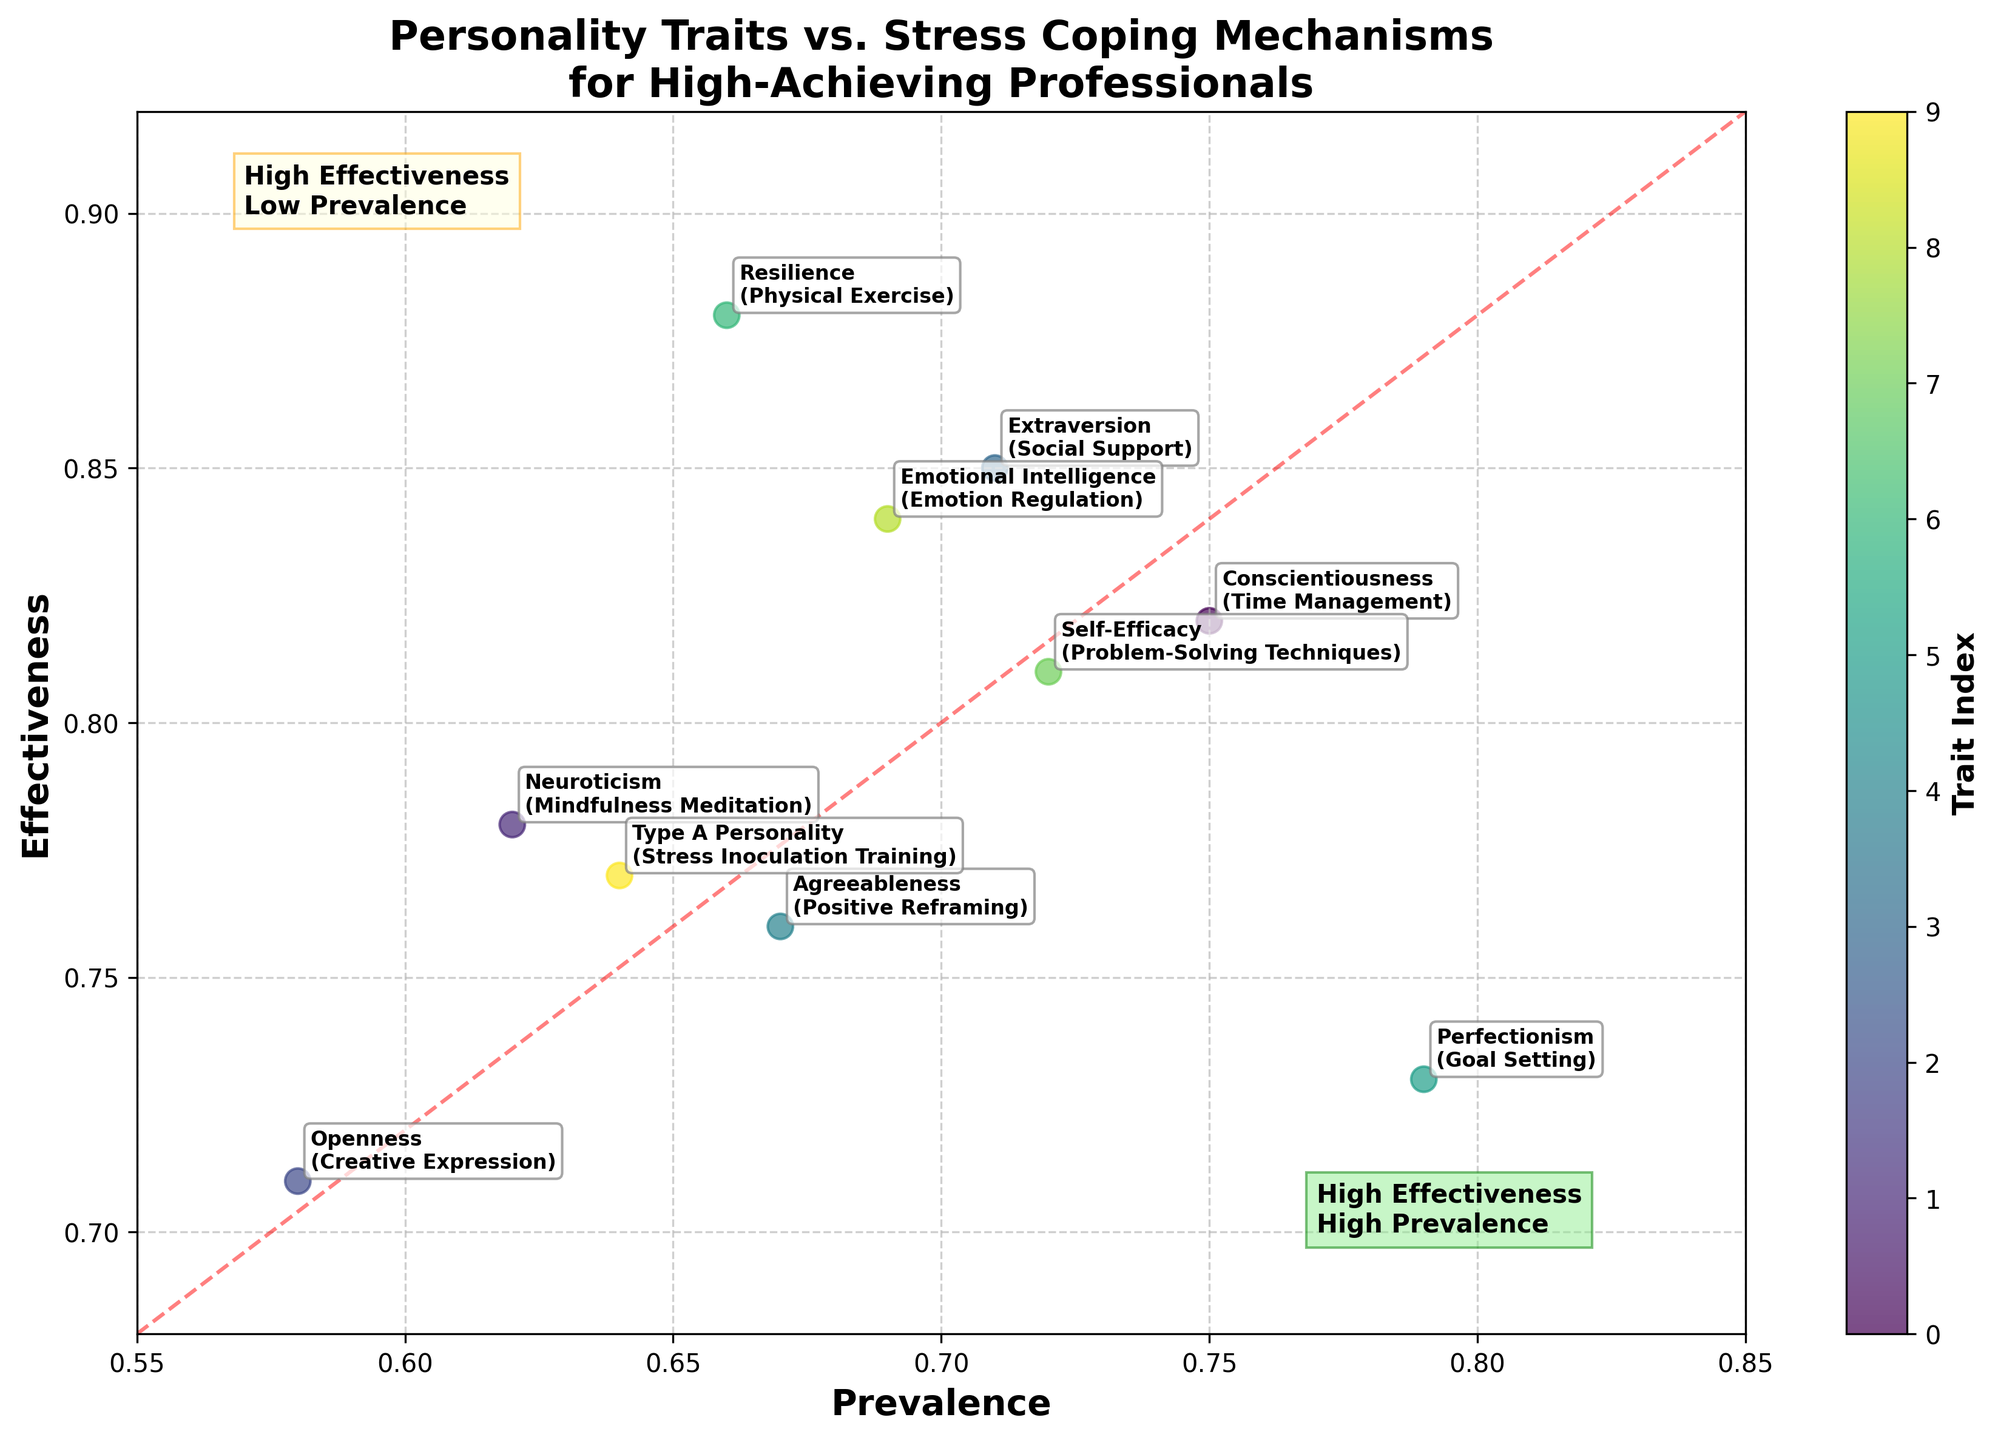How many data points are represented in the scatter plot? There are a total of 10 points representing different personality traits and their stress coping mechanisms. You can count the labeled points in the scatter plot to find this out.
Answer: 10 What is the title of the figure? The title is at the top of the figure and it reads "Personality Traits vs. Stress Coping Mechanisms for High-Achieving Professionals".
Answer: Personality Traits vs. Stress Coping Mechanisms for High-Achieving Professionals Which personality trait has the highest prevalence, and what is its corresponding stress coping mechanism? By looking at the scatter plot, the point farthest to the right represents the highest prevalence. The corresponding annotation indicates that the personality trait with the highest prevalence is "Perfectionism" and its stress coping mechanism is "Goal Setting".
Answer: Perfectionism, Goal Setting Which stress coping mechanism has the highest effectiveness and to which personality trait does it correspond? The point highest up on the y-axis represents the highest effectiveness. According to the annotations, the personality trait is "Resilience" and the stress coping mechanism is "Physical Exercise".
Answer: Physical Exercise, Resilience Where would you find traits with high effectiveness but low prevalence on the plot? These traits would be located in the top-left quadrant of the plot, above the diagonal line, and annotated as "High Effectiveness and Low Prevalence".
Answer: Top-left quadrant Which two traits have nearly identical prevalence but different effectiveness? Check for two points with similar x-axis positions but different y-axis positions. "Self-Efficacy" (Problem-Solving Techniques) and "Extraversion" (Social Support) both have a prevalence around 0.71–0.72 but different effectiveness.
Answer: Self-Efficacy and Extraversion Considering both axes, which personality trait's coping mechanism would you consider the least ideal in terms of both prevalence and effectiveness? Find the point on the scatter plot that is the lowest and farthest to the left. "Openness" with its coping mechanism "Creative Expression" seems to have the lowest combination of both prevalence (0.58) and effectiveness (0.71).
Answer: Openness, Creative Expression Which personality traits' coping mechanisms fall in the region annotated as "High Effectiveness and High Prevalence"? Points in the top-right quadrant above the diagonal line fall into this region. The traits are "Extraversion" (Social Support) and "Conscientiousness" (Time Management).
Answer: Extraversion, Conscientiousness What is the relationship between the prevalence and effectiveness of stress coping mechanisms for 'Agreeableness' and 'Type A Personality'? Which is higher? Compare the positions of these traits on the plot. "Agreeableness" has a slightly higher prevalence (0.67) and effectiveness (0.76) compared to "Type A Personality" (0.64 prevalence, 0.77 effectiveness). However, "Type A Personality" has higher effectiveness but lower prevalence.
Answer: Agreeableness has higher prevalence, Type A Personality has higher effectiveness 